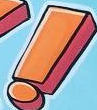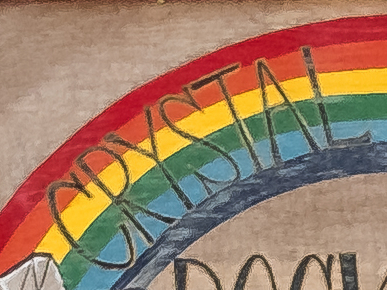What text appears in these images from left to right, separated by a semicolon? !; CRYSTAL 